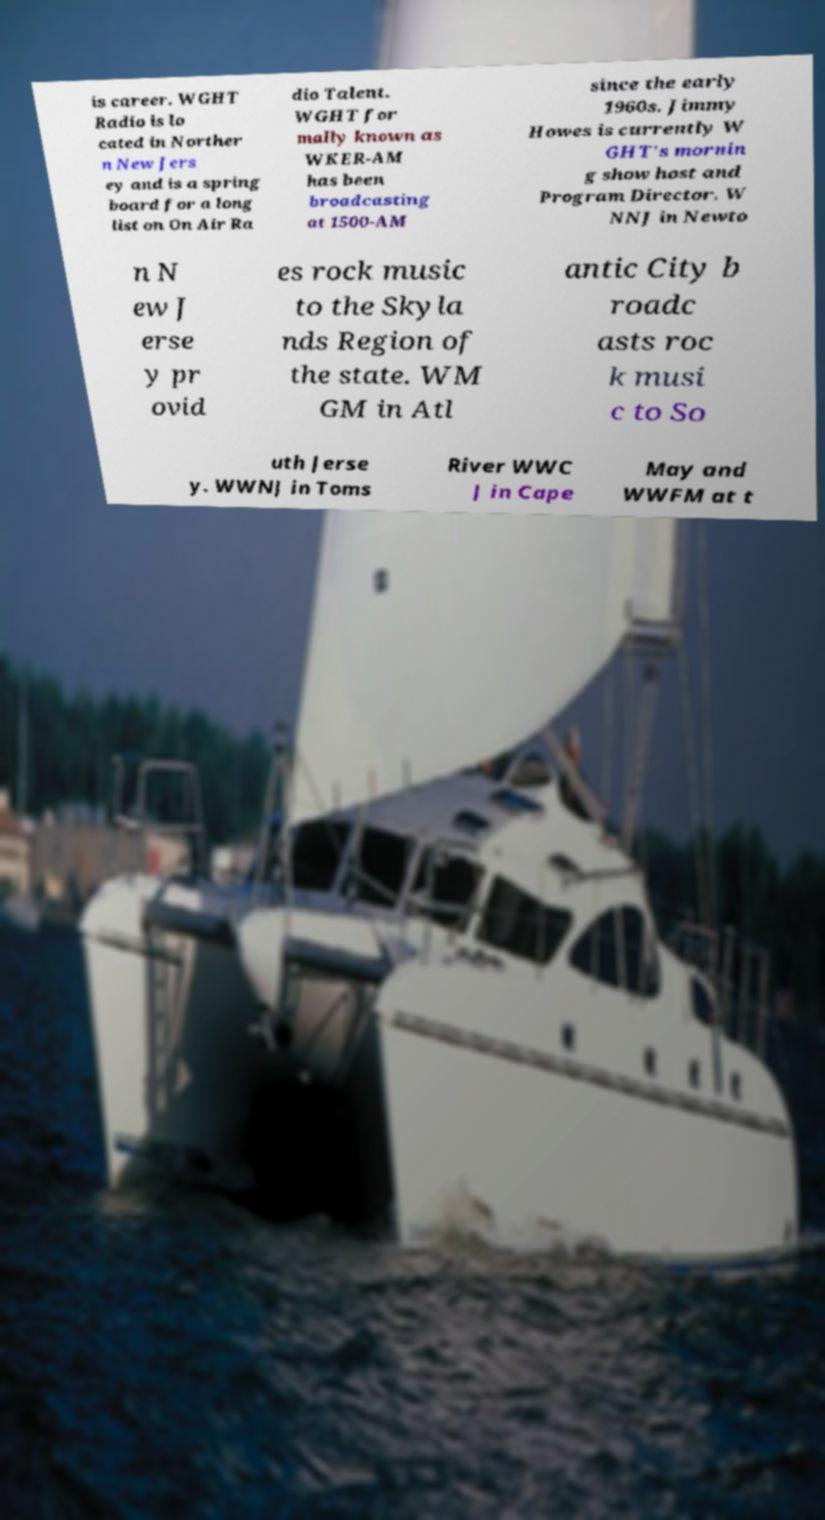Could you extract and type out the text from this image? is career. WGHT Radio is lo cated in Norther n New Jers ey and is a spring board for a long list on On Air Ra dio Talent. WGHT for mally known as WKER-AM has been broadcasting at 1500-AM since the early 1960s. Jimmy Howes is currently W GHT's mornin g show host and Program Director. W NNJ in Newto n N ew J erse y pr ovid es rock music to the Skyla nds Region of the state. WM GM in Atl antic City b roadc asts roc k musi c to So uth Jerse y. WWNJ in Toms River WWC J in Cape May and WWFM at t 